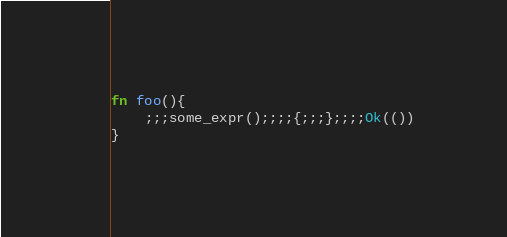<code> <loc_0><loc_0><loc_500><loc_500><_Rust_>fn foo(){
    ;;;some_expr();;;;{;;;};;;;Ok(())
}
</code> 